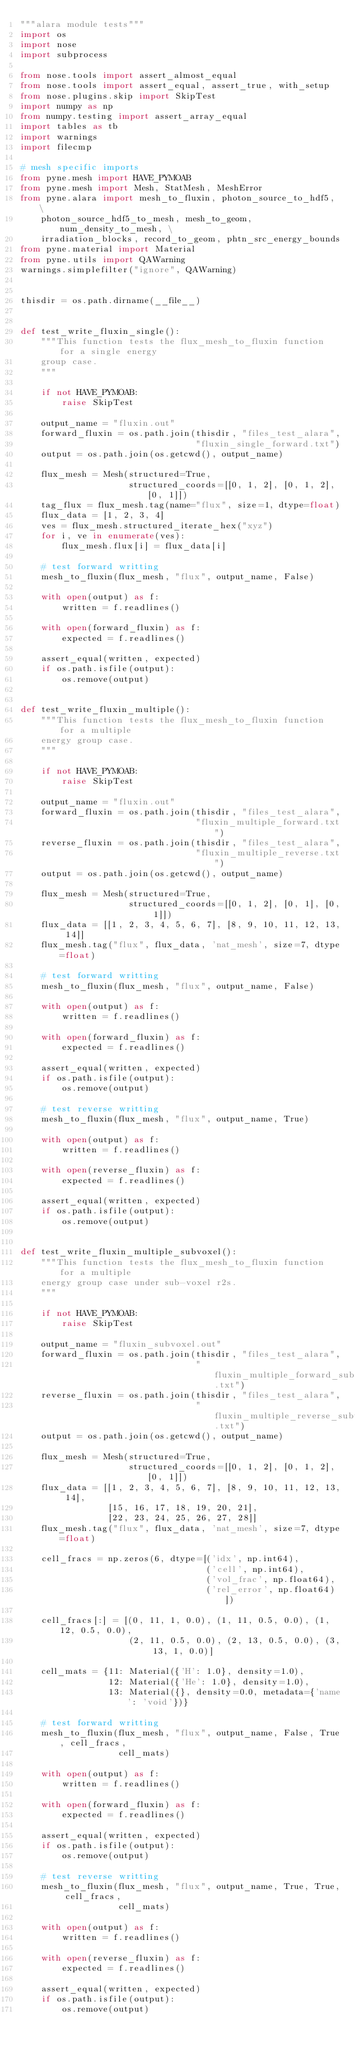Convert code to text. <code><loc_0><loc_0><loc_500><loc_500><_Python_>"""alara module tests"""
import os
import nose
import subprocess

from nose.tools import assert_almost_equal
from nose.tools import assert_equal, assert_true, with_setup
from nose.plugins.skip import SkipTest
import numpy as np
from numpy.testing import assert_array_equal
import tables as tb
import warnings
import filecmp

# mesh specific imports
from pyne.mesh import HAVE_PYMOAB
from pyne.mesh import Mesh, StatMesh, MeshError
from pyne.alara import mesh_to_fluxin, photon_source_to_hdf5, \
    photon_source_hdf5_to_mesh, mesh_to_geom, num_density_to_mesh, \
    irradiation_blocks, record_to_geom, phtn_src_energy_bounds
from pyne.material import Material
from pyne.utils import QAWarning
warnings.simplefilter("ignore", QAWarning)


thisdir = os.path.dirname(__file__)


def test_write_fluxin_single():
    """This function tests the flux_mesh_to_fluxin function for a single energy
    group case.
    """

    if not HAVE_PYMOAB:
        raise SkipTest

    output_name = "fluxin.out"
    forward_fluxin = os.path.join(thisdir, "files_test_alara",
                                  "fluxin_single_forward.txt")
    output = os.path.join(os.getcwd(), output_name)

    flux_mesh = Mesh(structured=True,
                     structured_coords=[[0, 1, 2], [0, 1, 2], [0, 1]])
    tag_flux = flux_mesh.tag(name="flux", size=1, dtype=float)
    flux_data = [1, 2, 3, 4]
    ves = flux_mesh.structured_iterate_hex("xyz")
    for i, ve in enumerate(ves):
        flux_mesh.flux[i] = flux_data[i]

    # test forward writting
    mesh_to_fluxin(flux_mesh, "flux", output_name, False)

    with open(output) as f:
        written = f.readlines()

    with open(forward_fluxin) as f:
        expected = f.readlines()

    assert_equal(written, expected)
    if os.path.isfile(output):
        os.remove(output)


def test_write_fluxin_multiple():
    """This function tests the flux_mesh_to_fluxin function for a multiple
    energy group case.
    """

    if not HAVE_PYMOAB:
        raise SkipTest

    output_name = "fluxin.out"
    forward_fluxin = os.path.join(thisdir, "files_test_alara",
                                  "fluxin_multiple_forward.txt")
    reverse_fluxin = os.path.join(thisdir, "files_test_alara",
                                  "fluxin_multiple_reverse.txt")
    output = os.path.join(os.getcwd(), output_name)

    flux_mesh = Mesh(structured=True,
                     structured_coords=[[0, 1, 2], [0, 1], [0, 1]])
    flux_data = [[1, 2, 3, 4, 5, 6, 7], [8, 9, 10, 11, 12, 13, 14]]
    flux_mesh.tag("flux", flux_data, 'nat_mesh', size=7, dtype=float)

    # test forward writting
    mesh_to_fluxin(flux_mesh, "flux", output_name, False)

    with open(output) as f:
        written = f.readlines()

    with open(forward_fluxin) as f:
        expected = f.readlines()

    assert_equal(written, expected)
    if os.path.isfile(output):
        os.remove(output)

    # test reverse writting
    mesh_to_fluxin(flux_mesh, "flux", output_name, True)

    with open(output) as f:
        written = f.readlines()

    with open(reverse_fluxin) as f:
        expected = f.readlines()

    assert_equal(written, expected)
    if os.path.isfile(output):
        os.remove(output)


def test_write_fluxin_multiple_subvoxel():
    """This function tests the flux_mesh_to_fluxin function for a multiple
    energy group case under sub-voxel r2s.
    """

    if not HAVE_PYMOAB:
        raise SkipTest

    output_name = "fluxin_subvoxel.out"
    forward_fluxin = os.path.join(thisdir, "files_test_alara",
                                  "fluxin_multiple_forward_subvoxel.txt")
    reverse_fluxin = os.path.join(thisdir, "files_test_alara",
                                  "fluxin_multiple_reverse_subvoxel.txt")
    output = os.path.join(os.getcwd(), output_name)

    flux_mesh = Mesh(structured=True,
                     structured_coords=[[0, 1, 2], [0, 1, 2], [0, 1]])
    flux_data = [[1, 2, 3, 4, 5, 6, 7], [8, 9, 10, 11, 12, 13, 14],
                 [15, 16, 17, 18, 19, 20, 21],
                 [22, 23, 24, 25, 26, 27, 28]]
    flux_mesh.tag("flux", flux_data, 'nat_mesh', size=7, dtype=float)

    cell_fracs = np.zeros(6, dtype=[('idx', np.int64),
                                    ('cell', np.int64),
                                    ('vol_frac', np.float64),
                                    ('rel_error', np.float64)])

    cell_fracs[:] = [(0, 11, 1, 0.0), (1, 11, 0.5, 0.0), (1, 12, 0.5, 0.0),
                     (2, 11, 0.5, 0.0), (2, 13, 0.5, 0.0), (3, 13, 1, 0.0)]

    cell_mats = {11: Material({'H': 1.0}, density=1.0),
                 12: Material({'He': 1.0}, density=1.0),
                 13: Material({}, density=0.0, metadata={'name': 'void'})}

    # test forward writting
    mesh_to_fluxin(flux_mesh, "flux", output_name, False, True, cell_fracs,
                   cell_mats)

    with open(output) as f:
        written = f.readlines()

    with open(forward_fluxin) as f:
        expected = f.readlines()

    assert_equal(written, expected)
    if os.path.isfile(output):
        os.remove(output)

    # test reverse writting
    mesh_to_fluxin(flux_mesh, "flux", output_name, True, True, cell_fracs,
                   cell_mats)

    with open(output) as f:
        written = f.readlines()

    with open(reverse_fluxin) as f:
        expected = f.readlines()

    assert_equal(written, expected)
    if os.path.isfile(output):
        os.remove(output)

</code> 